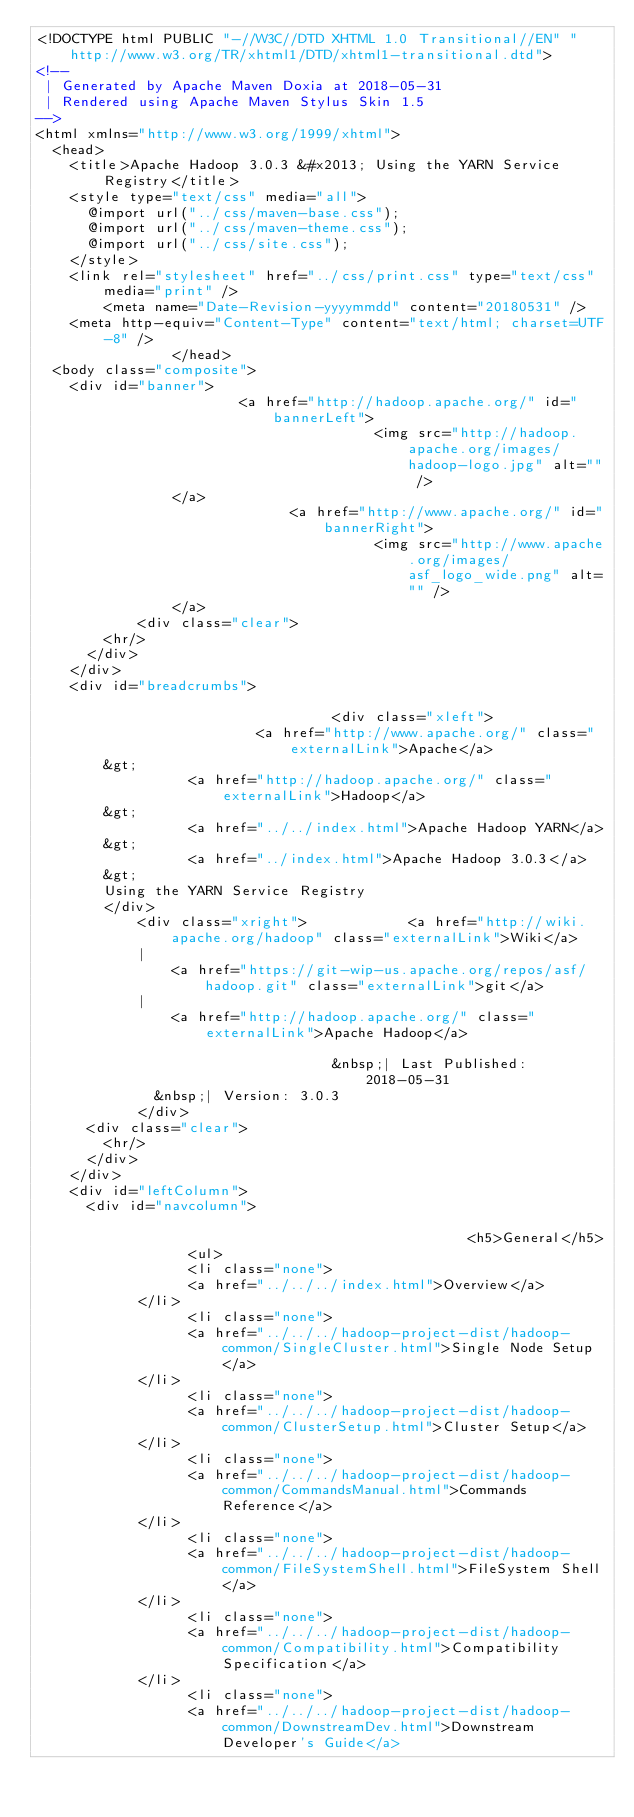<code> <loc_0><loc_0><loc_500><loc_500><_HTML_><!DOCTYPE html PUBLIC "-//W3C//DTD XHTML 1.0 Transitional//EN" "http://www.w3.org/TR/xhtml1/DTD/xhtml1-transitional.dtd">
<!--
 | Generated by Apache Maven Doxia at 2018-05-31
 | Rendered using Apache Maven Stylus Skin 1.5
-->
<html xmlns="http://www.w3.org/1999/xhtml">
  <head>
    <title>Apache Hadoop 3.0.3 &#x2013; Using the YARN Service Registry</title>
    <style type="text/css" media="all">
      @import url("../css/maven-base.css");
      @import url("../css/maven-theme.css");
      @import url("../css/site.css");
    </style>
    <link rel="stylesheet" href="../css/print.css" type="text/css" media="print" />
        <meta name="Date-Revision-yyyymmdd" content="20180531" />
    <meta http-equiv="Content-Type" content="text/html; charset=UTF-8" />
                </head>
  <body class="composite">
    <div id="banner">
                        <a href="http://hadoop.apache.org/" id="bannerLeft">
                                        <img src="http://hadoop.apache.org/images/hadoop-logo.jpg" alt="" />
                </a>
                              <a href="http://www.apache.org/" id="bannerRight">
                                        <img src="http://www.apache.org/images/asf_logo_wide.png" alt="" />
                </a>
            <div class="clear">
        <hr/>
      </div>
    </div>
    <div id="breadcrumbs">
            
                                   <div class="xleft">
                          <a href="http://www.apache.org/" class="externalLink">Apache</a>
        &gt;
                  <a href="http://hadoop.apache.org/" class="externalLink">Hadoop</a>
        &gt;
                  <a href="../../index.html">Apache Hadoop YARN</a>
        &gt;
                  <a href="../index.html">Apache Hadoop 3.0.3</a>
        &gt;
        Using the YARN Service Registry
        </div>
            <div class="xright">            <a href="http://wiki.apache.org/hadoop" class="externalLink">Wiki</a>
            |
                <a href="https://git-wip-us.apache.org/repos/asf/hadoop.git" class="externalLink">git</a>
            |
                <a href="http://hadoop.apache.org/" class="externalLink">Apache Hadoop</a>
              
                                   &nbsp;| Last Published: 2018-05-31
              &nbsp;| Version: 3.0.3
            </div>
      <div class="clear">
        <hr/>
      </div>
    </div>
    <div id="leftColumn">
      <div id="navcolumn">
             
                                                   <h5>General</h5>
                  <ul>
                  <li class="none">
                  <a href="../../../index.html">Overview</a>
            </li>
                  <li class="none">
                  <a href="../../../hadoop-project-dist/hadoop-common/SingleCluster.html">Single Node Setup</a>
            </li>
                  <li class="none">
                  <a href="../../../hadoop-project-dist/hadoop-common/ClusterSetup.html">Cluster Setup</a>
            </li>
                  <li class="none">
                  <a href="../../../hadoop-project-dist/hadoop-common/CommandsManual.html">Commands Reference</a>
            </li>
                  <li class="none">
                  <a href="../../../hadoop-project-dist/hadoop-common/FileSystemShell.html">FileSystem Shell</a>
            </li>
                  <li class="none">
                  <a href="../../../hadoop-project-dist/hadoop-common/Compatibility.html">Compatibility Specification</a>
            </li>
                  <li class="none">
                  <a href="../../../hadoop-project-dist/hadoop-common/DownstreamDev.html">Downstream Developer's Guide</a></code> 